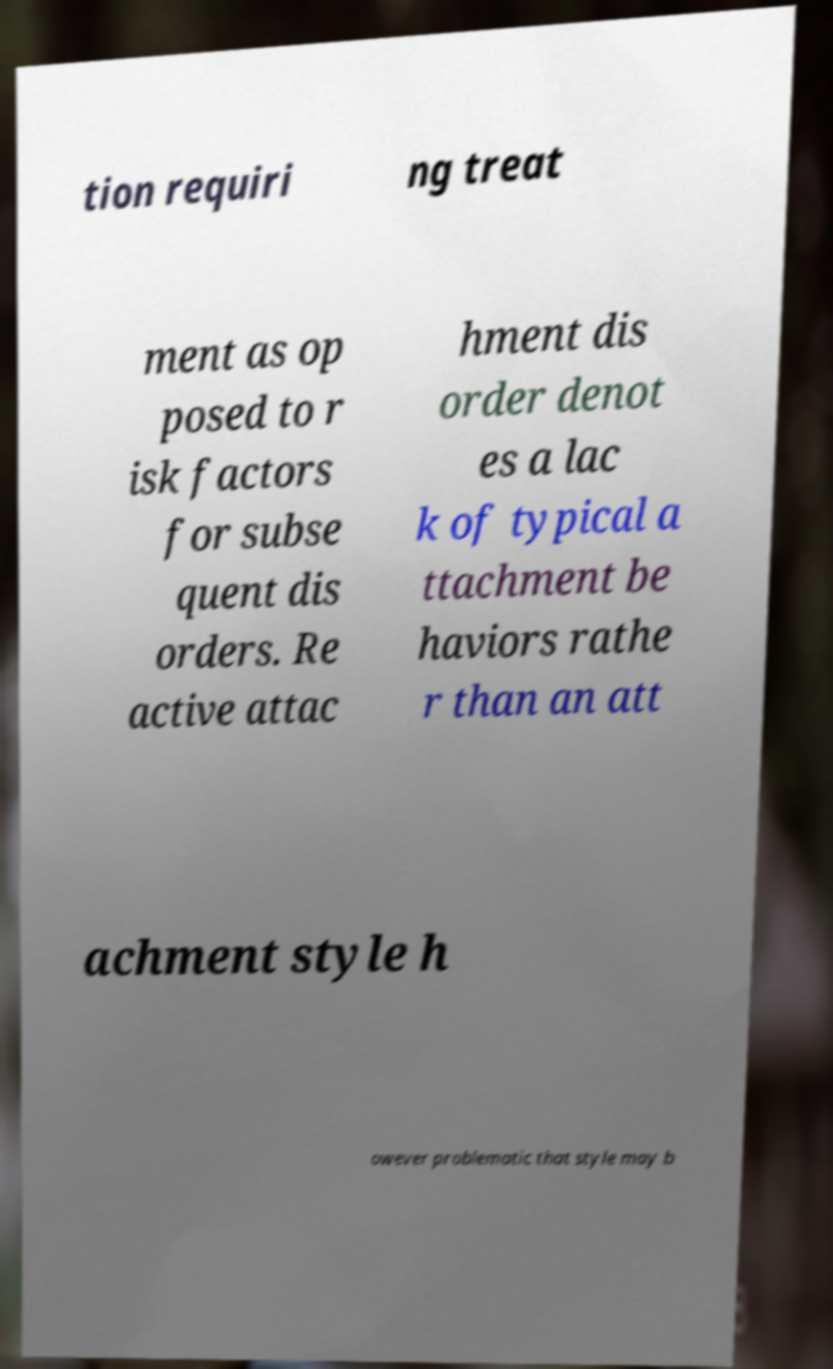For documentation purposes, I need the text within this image transcribed. Could you provide that? tion requiri ng treat ment as op posed to r isk factors for subse quent dis orders. Re active attac hment dis order denot es a lac k of typical a ttachment be haviors rathe r than an att achment style h owever problematic that style may b 